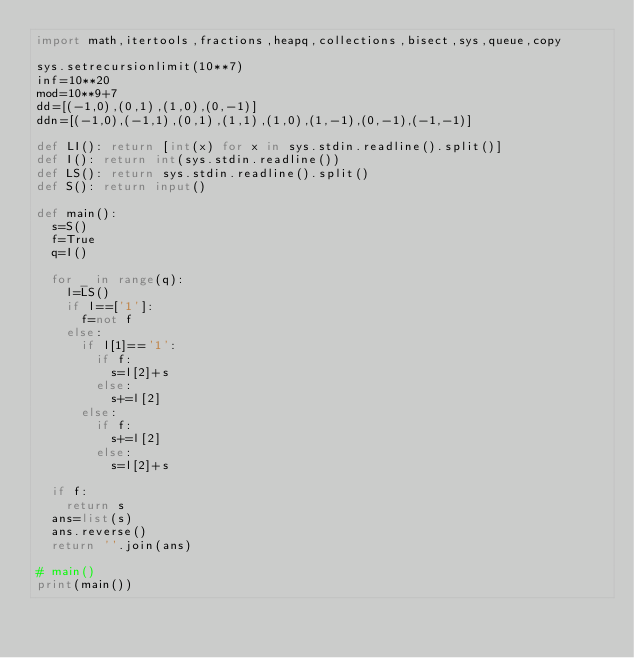<code> <loc_0><loc_0><loc_500><loc_500><_Python_>import math,itertools,fractions,heapq,collections,bisect,sys,queue,copy

sys.setrecursionlimit(10**7)
inf=10**20
mod=10**9+7
dd=[(-1,0),(0,1),(1,0),(0,-1)]
ddn=[(-1,0),(-1,1),(0,1),(1,1),(1,0),(1,-1),(0,-1),(-1,-1)]

def LI(): return [int(x) for x in sys.stdin.readline().split()]
def I(): return int(sys.stdin.readline())
def LS(): return sys.stdin.readline().split()
def S(): return input()

def main():
  s=S()
  f=True
  q=I()

  for _ in range(q):
    l=LS()
    if l==['1']:
      f=not f
    else:
      if l[1]=='1':
        if f:
          s=l[2]+s
        else:
          s+=l[2]
      else:
        if f:
          s+=l[2]
        else:
          s=l[2]+s

  if f:
    return s
  ans=list(s)
  ans.reverse()
  return ''.join(ans)

# main()
print(main())
</code> 